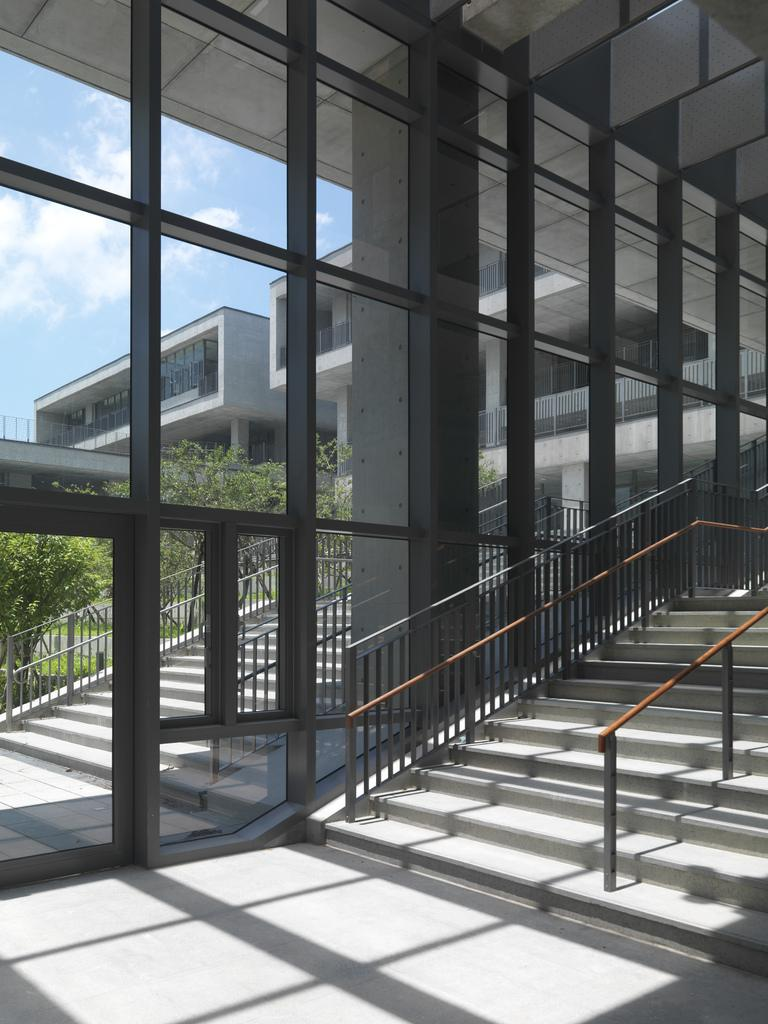What is visible on the ground in the image? The floor is visible in the image. What material is present in the image that is transparent or translucent? There is glass in the image. What architectural feature is present in the image that allows for vertical movement? There are stairs in the image. What safety feature is present in the image to prevent falls? Railings are present in the image. What type of structures can be seen in the image? There are buildings in the image. What type of vegetation is visible in the image? Trees are visible in the image. What objects are present in the image? There are objects in the image. What is visible in the background of the image? The sky is visible in the background of the image. What atmospheric feature can be seen in the sky? Clouds are present in the sky. What month is it in the image? The month cannot be determined from the image, as it does not contain any information about the time of year. Can you identify the man in the image? There is no man present in the image. Who is the writer of the text on the objects in the image? There is no text or writer mentioned in the image. 